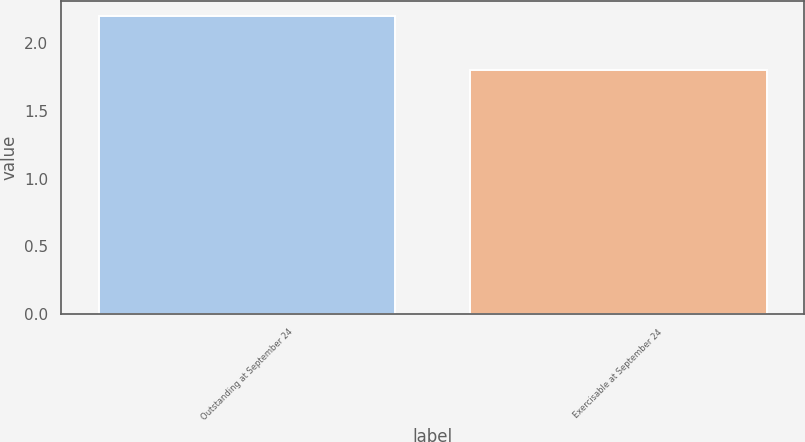Convert chart to OTSL. <chart><loc_0><loc_0><loc_500><loc_500><bar_chart><fcel>Outstanding at September 24<fcel>Exercisable at September 24<nl><fcel>2.2<fcel>1.8<nl></chart> 